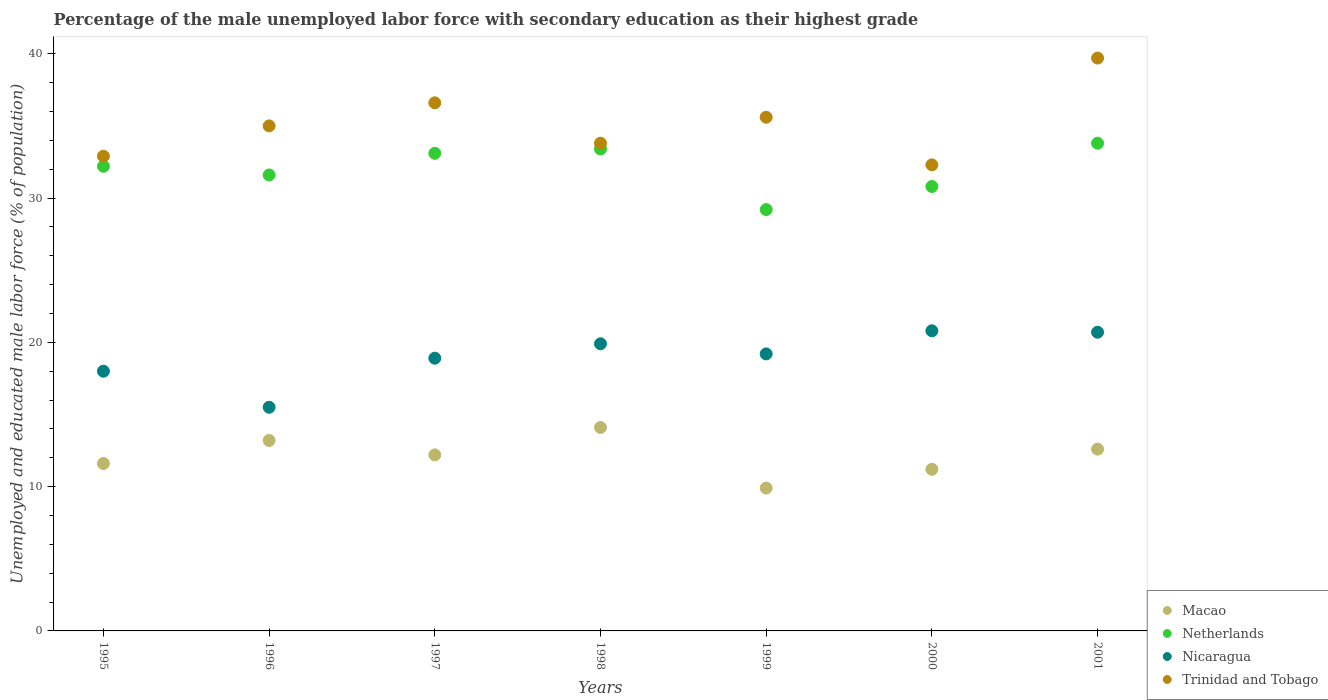How many different coloured dotlines are there?
Your answer should be very brief. 4. What is the percentage of the unemployed male labor force with secondary education in Netherlands in 2001?
Make the answer very short. 33.8. Across all years, what is the maximum percentage of the unemployed male labor force with secondary education in Trinidad and Tobago?
Make the answer very short. 39.7. Across all years, what is the minimum percentage of the unemployed male labor force with secondary education in Macao?
Keep it short and to the point. 9.9. What is the total percentage of the unemployed male labor force with secondary education in Macao in the graph?
Your answer should be compact. 84.8. What is the difference between the percentage of the unemployed male labor force with secondary education in Nicaragua in 1998 and that in 2001?
Give a very brief answer. -0.8. What is the difference between the percentage of the unemployed male labor force with secondary education in Macao in 1997 and the percentage of the unemployed male labor force with secondary education in Nicaragua in 1995?
Offer a terse response. -5.8. What is the average percentage of the unemployed male labor force with secondary education in Trinidad and Tobago per year?
Offer a terse response. 35.13. In the year 1997, what is the difference between the percentage of the unemployed male labor force with secondary education in Trinidad and Tobago and percentage of the unemployed male labor force with secondary education in Macao?
Offer a very short reply. 24.4. What is the ratio of the percentage of the unemployed male labor force with secondary education in Nicaragua in 1998 to that in 2000?
Keep it short and to the point. 0.96. Is the difference between the percentage of the unemployed male labor force with secondary education in Trinidad and Tobago in 1996 and 2000 greater than the difference between the percentage of the unemployed male labor force with secondary education in Macao in 1996 and 2000?
Keep it short and to the point. Yes. What is the difference between the highest and the second highest percentage of the unemployed male labor force with secondary education in Macao?
Offer a very short reply. 0.9. What is the difference between the highest and the lowest percentage of the unemployed male labor force with secondary education in Macao?
Offer a very short reply. 4.2. How many years are there in the graph?
Offer a very short reply. 7. Does the graph contain any zero values?
Offer a very short reply. No. Where does the legend appear in the graph?
Provide a short and direct response. Bottom right. What is the title of the graph?
Offer a very short reply. Percentage of the male unemployed labor force with secondary education as their highest grade. Does "Belarus" appear as one of the legend labels in the graph?
Ensure brevity in your answer.  No. What is the label or title of the Y-axis?
Keep it short and to the point. Unemployed and educated male labor force (% of population). What is the Unemployed and educated male labor force (% of population) in Macao in 1995?
Offer a terse response. 11.6. What is the Unemployed and educated male labor force (% of population) in Netherlands in 1995?
Ensure brevity in your answer.  32.2. What is the Unemployed and educated male labor force (% of population) in Nicaragua in 1995?
Make the answer very short. 18. What is the Unemployed and educated male labor force (% of population) of Trinidad and Tobago in 1995?
Your answer should be compact. 32.9. What is the Unemployed and educated male labor force (% of population) in Macao in 1996?
Make the answer very short. 13.2. What is the Unemployed and educated male labor force (% of population) in Netherlands in 1996?
Offer a terse response. 31.6. What is the Unemployed and educated male labor force (% of population) of Nicaragua in 1996?
Ensure brevity in your answer.  15.5. What is the Unemployed and educated male labor force (% of population) in Trinidad and Tobago in 1996?
Keep it short and to the point. 35. What is the Unemployed and educated male labor force (% of population) of Macao in 1997?
Keep it short and to the point. 12.2. What is the Unemployed and educated male labor force (% of population) of Netherlands in 1997?
Keep it short and to the point. 33.1. What is the Unemployed and educated male labor force (% of population) in Nicaragua in 1997?
Your response must be concise. 18.9. What is the Unemployed and educated male labor force (% of population) of Trinidad and Tobago in 1997?
Your response must be concise. 36.6. What is the Unemployed and educated male labor force (% of population) of Macao in 1998?
Ensure brevity in your answer.  14.1. What is the Unemployed and educated male labor force (% of population) of Netherlands in 1998?
Keep it short and to the point. 33.4. What is the Unemployed and educated male labor force (% of population) of Nicaragua in 1998?
Offer a very short reply. 19.9. What is the Unemployed and educated male labor force (% of population) of Trinidad and Tobago in 1998?
Ensure brevity in your answer.  33.8. What is the Unemployed and educated male labor force (% of population) in Macao in 1999?
Make the answer very short. 9.9. What is the Unemployed and educated male labor force (% of population) of Netherlands in 1999?
Your answer should be compact. 29.2. What is the Unemployed and educated male labor force (% of population) in Nicaragua in 1999?
Your response must be concise. 19.2. What is the Unemployed and educated male labor force (% of population) of Trinidad and Tobago in 1999?
Provide a short and direct response. 35.6. What is the Unemployed and educated male labor force (% of population) in Macao in 2000?
Your response must be concise. 11.2. What is the Unemployed and educated male labor force (% of population) in Netherlands in 2000?
Your answer should be compact. 30.8. What is the Unemployed and educated male labor force (% of population) in Nicaragua in 2000?
Provide a succinct answer. 20.8. What is the Unemployed and educated male labor force (% of population) in Trinidad and Tobago in 2000?
Make the answer very short. 32.3. What is the Unemployed and educated male labor force (% of population) in Macao in 2001?
Provide a succinct answer. 12.6. What is the Unemployed and educated male labor force (% of population) of Netherlands in 2001?
Give a very brief answer. 33.8. What is the Unemployed and educated male labor force (% of population) in Nicaragua in 2001?
Ensure brevity in your answer.  20.7. What is the Unemployed and educated male labor force (% of population) of Trinidad and Tobago in 2001?
Give a very brief answer. 39.7. Across all years, what is the maximum Unemployed and educated male labor force (% of population) of Macao?
Offer a very short reply. 14.1. Across all years, what is the maximum Unemployed and educated male labor force (% of population) of Netherlands?
Your answer should be very brief. 33.8. Across all years, what is the maximum Unemployed and educated male labor force (% of population) in Nicaragua?
Provide a short and direct response. 20.8. Across all years, what is the maximum Unemployed and educated male labor force (% of population) in Trinidad and Tobago?
Make the answer very short. 39.7. Across all years, what is the minimum Unemployed and educated male labor force (% of population) in Macao?
Your answer should be compact. 9.9. Across all years, what is the minimum Unemployed and educated male labor force (% of population) of Netherlands?
Offer a very short reply. 29.2. Across all years, what is the minimum Unemployed and educated male labor force (% of population) in Nicaragua?
Keep it short and to the point. 15.5. Across all years, what is the minimum Unemployed and educated male labor force (% of population) of Trinidad and Tobago?
Provide a short and direct response. 32.3. What is the total Unemployed and educated male labor force (% of population) of Macao in the graph?
Provide a succinct answer. 84.8. What is the total Unemployed and educated male labor force (% of population) of Netherlands in the graph?
Your answer should be very brief. 224.1. What is the total Unemployed and educated male labor force (% of population) of Nicaragua in the graph?
Your answer should be very brief. 133. What is the total Unemployed and educated male labor force (% of population) of Trinidad and Tobago in the graph?
Provide a short and direct response. 245.9. What is the difference between the Unemployed and educated male labor force (% of population) of Trinidad and Tobago in 1995 and that in 1996?
Offer a very short reply. -2.1. What is the difference between the Unemployed and educated male labor force (% of population) in Macao in 1995 and that in 1997?
Your answer should be compact. -0.6. What is the difference between the Unemployed and educated male labor force (% of population) in Netherlands in 1995 and that in 1998?
Ensure brevity in your answer.  -1.2. What is the difference between the Unemployed and educated male labor force (% of population) of Netherlands in 1995 and that in 1999?
Ensure brevity in your answer.  3. What is the difference between the Unemployed and educated male labor force (% of population) of Trinidad and Tobago in 1995 and that in 1999?
Keep it short and to the point. -2.7. What is the difference between the Unemployed and educated male labor force (% of population) of Netherlands in 1995 and that in 2000?
Provide a short and direct response. 1.4. What is the difference between the Unemployed and educated male labor force (% of population) in Nicaragua in 1995 and that in 2000?
Offer a terse response. -2.8. What is the difference between the Unemployed and educated male labor force (% of population) of Netherlands in 1995 and that in 2001?
Give a very brief answer. -1.6. What is the difference between the Unemployed and educated male labor force (% of population) of Nicaragua in 1995 and that in 2001?
Ensure brevity in your answer.  -2.7. What is the difference between the Unemployed and educated male labor force (% of population) of Trinidad and Tobago in 1995 and that in 2001?
Provide a short and direct response. -6.8. What is the difference between the Unemployed and educated male labor force (% of population) in Macao in 1996 and that in 1997?
Make the answer very short. 1. What is the difference between the Unemployed and educated male labor force (% of population) in Trinidad and Tobago in 1996 and that in 1997?
Give a very brief answer. -1.6. What is the difference between the Unemployed and educated male labor force (% of population) in Trinidad and Tobago in 1996 and that in 1998?
Ensure brevity in your answer.  1.2. What is the difference between the Unemployed and educated male labor force (% of population) in Macao in 1996 and that in 1999?
Provide a short and direct response. 3.3. What is the difference between the Unemployed and educated male labor force (% of population) of Netherlands in 1996 and that in 1999?
Provide a succinct answer. 2.4. What is the difference between the Unemployed and educated male labor force (% of population) of Nicaragua in 1996 and that in 1999?
Provide a succinct answer. -3.7. What is the difference between the Unemployed and educated male labor force (% of population) in Trinidad and Tobago in 1996 and that in 1999?
Offer a terse response. -0.6. What is the difference between the Unemployed and educated male labor force (% of population) of Macao in 1996 and that in 2000?
Your answer should be very brief. 2. What is the difference between the Unemployed and educated male labor force (% of population) of Nicaragua in 1996 and that in 2000?
Your response must be concise. -5.3. What is the difference between the Unemployed and educated male labor force (% of population) of Netherlands in 1996 and that in 2001?
Provide a short and direct response. -2.2. What is the difference between the Unemployed and educated male labor force (% of population) of Macao in 1997 and that in 1998?
Provide a short and direct response. -1.9. What is the difference between the Unemployed and educated male labor force (% of population) of Nicaragua in 1997 and that in 1998?
Provide a succinct answer. -1. What is the difference between the Unemployed and educated male labor force (% of population) in Macao in 1997 and that in 1999?
Keep it short and to the point. 2.3. What is the difference between the Unemployed and educated male labor force (% of population) in Netherlands in 1997 and that in 1999?
Your answer should be compact. 3.9. What is the difference between the Unemployed and educated male labor force (% of population) of Trinidad and Tobago in 1997 and that in 1999?
Provide a short and direct response. 1. What is the difference between the Unemployed and educated male labor force (% of population) of Macao in 1997 and that in 2000?
Your answer should be very brief. 1. What is the difference between the Unemployed and educated male labor force (% of population) of Netherlands in 1997 and that in 2000?
Provide a short and direct response. 2.3. What is the difference between the Unemployed and educated male labor force (% of population) of Trinidad and Tobago in 1997 and that in 2000?
Your answer should be very brief. 4.3. What is the difference between the Unemployed and educated male labor force (% of population) in Macao in 1997 and that in 2001?
Your answer should be very brief. -0.4. What is the difference between the Unemployed and educated male labor force (% of population) in Nicaragua in 1997 and that in 2001?
Provide a short and direct response. -1.8. What is the difference between the Unemployed and educated male labor force (% of population) in Macao in 1998 and that in 1999?
Ensure brevity in your answer.  4.2. What is the difference between the Unemployed and educated male labor force (% of population) in Nicaragua in 1998 and that in 1999?
Your answer should be very brief. 0.7. What is the difference between the Unemployed and educated male labor force (% of population) of Netherlands in 1998 and that in 2000?
Offer a terse response. 2.6. What is the difference between the Unemployed and educated male labor force (% of population) in Nicaragua in 1998 and that in 2000?
Your response must be concise. -0.9. What is the difference between the Unemployed and educated male labor force (% of population) in Trinidad and Tobago in 1998 and that in 2000?
Give a very brief answer. 1.5. What is the difference between the Unemployed and educated male labor force (% of population) of Nicaragua in 1998 and that in 2001?
Offer a terse response. -0.8. What is the difference between the Unemployed and educated male labor force (% of population) in Macao in 1999 and that in 2000?
Make the answer very short. -1.3. What is the difference between the Unemployed and educated male labor force (% of population) in Trinidad and Tobago in 1999 and that in 2001?
Your response must be concise. -4.1. What is the difference between the Unemployed and educated male labor force (% of population) of Netherlands in 2000 and that in 2001?
Provide a short and direct response. -3. What is the difference between the Unemployed and educated male labor force (% of population) of Nicaragua in 2000 and that in 2001?
Your response must be concise. 0.1. What is the difference between the Unemployed and educated male labor force (% of population) of Macao in 1995 and the Unemployed and educated male labor force (% of population) of Netherlands in 1996?
Provide a succinct answer. -20. What is the difference between the Unemployed and educated male labor force (% of population) of Macao in 1995 and the Unemployed and educated male labor force (% of population) of Trinidad and Tobago in 1996?
Make the answer very short. -23.4. What is the difference between the Unemployed and educated male labor force (% of population) in Netherlands in 1995 and the Unemployed and educated male labor force (% of population) in Nicaragua in 1996?
Keep it short and to the point. 16.7. What is the difference between the Unemployed and educated male labor force (% of population) in Netherlands in 1995 and the Unemployed and educated male labor force (% of population) in Trinidad and Tobago in 1996?
Give a very brief answer. -2.8. What is the difference between the Unemployed and educated male labor force (% of population) in Macao in 1995 and the Unemployed and educated male labor force (% of population) in Netherlands in 1997?
Your answer should be very brief. -21.5. What is the difference between the Unemployed and educated male labor force (% of population) in Macao in 1995 and the Unemployed and educated male labor force (% of population) in Nicaragua in 1997?
Make the answer very short. -7.3. What is the difference between the Unemployed and educated male labor force (% of population) in Nicaragua in 1995 and the Unemployed and educated male labor force (% of population) in Trinidad and Tobago in 1997?
Your response must be concise. -18.6. What is the difference between the Unemployed and educated male labor force (% of population) of Macao in 1995 and the Unemployed and educated male labor force (% of population) of Netherlands in 1998?
Keep it short and to the point. -21.8. What is the difference between the Unemployed and educated male labor force (% of population) of Macao in 1995 and the Unemployed and educated male labor force (% of population) of Trinidad and Tobago in 1998?
Provide a short and direct response. -22.2. What is the difference between the Unemployed and educated male labor force (% of population) in Nicaragua in 1995 and the Unemployed and educated male labor force (% of population) in Trinidad and Tobago in 1998?
Your answer should be very brief. -15.8. What is the difference between the Unemployed and educated male labor force (% of population) of Macao in 1995 and the Unemployed and educated male labor force (% of population) of Netherlands in 1999?
Your answer should be very brief. -17.6. What is the difference between the Unemployed and educated male labor force (% of population) of Netherlands in 1995 and the Unemployed and educated male labor force (% of population) of Nicaragua in 1999?
Give a very brief answer. 13. What is the difference between the Unemployed and educated male labor force (% of population) of Netherlands in 1995 and the Unemployed and educated male labor force (% of population) of Trinidad and Tobago in 1999?
Your answer should be very brief. -3.4. What is the difference between the Unemployed and educated male labor force (% of population) of Nicaragua in 1995 and the Unemployed and educated male labor force (% of population) of Trinidad and Tobago in 1999?
Offer a terse response. -17.6. What is the difference between the Unemployed and educated male labor force (% of population) of Macao in 1995 and the Unemployed and educated male labor force (% of population) of Netherlands in 2000?
Your response must be concise. -19.2. What is the difference between the Unemployed and educated male labor force (% of population) in Macao in 1995 and the Unemployed and educated male labor force (% of population) in Nicaragua in 2000?
Offer a terse response. -9.2. What is the difference between the Unemployed and educated male labor force (% of population) in Macao in 1995 and the Unemployed and educated male labor force (% of population) in Trinidad and Tobago in 2000?
Provide a short and direct response. -20.7. What is the difference between the Unemployed and educated male labor force (% of population) of Netherlands in 1995 and the Unemployed and educated male labor force (% of population) of Trinidad and Tobago in 2000?
Make the answer very short. -0.1. What is the difference between the Unemployed and educated male labor force (% of population) in Nicaragua in 1995 and the Unemployed and educated male labor force (% of population) in Trinidad and Tobago in 2000?
Give a very brief answer. -14.3. What is the difference between the Unemployed and educated male labor force (% of population) in Macao in 1995 and the Unemployed and educated male labor force (% of population) in Netherlands in 2001?
Make the answer very short. -22.2. What is the difference between the Unemployed and educated male labor force (% of population) in Macao in 1995 and the Unemployed and educated male labor force (% of population) in Nicaragua in 2001?
Provide a succinct answer. -9.1. What is the difference between the Unemployed and educated male labor force (% of population) of Macao in 1995 and the Unemployed and educated male labor force (% of population) of Trinidad and Tobago in 2001?
Your response must be concise. -28.1. What is the difference between the Unemployed and educated male labor force (% of population) in Netherlands in 1995 and the Unemployed and educated male labor force (% of population) in Nicaragua in 2001?
Your response must be concise. 11.5. What is the difference between the Unemployed and educated male labor force (% of population) in Nicaragua in 1995 and the Unemployed and educated male labor force (% of population) in Trinidad and Tobago in 2001?
Offer a very short reply. -21.7. What is the difference between the Unemployed and educated male labor force (% of population) in Macao in 1996 and the Unemployed and educated male labor force (% of population) in Netherlands in 1997?
Provide a short and direct response. -19.9. What is the difference between the Unemployed and educated male labor force (% of population) in Macao in 1996 and the Unemployed and educated male labor force (% of population) in Trinidad and Tobago in 1997?
Make the answer very short. -23.4. What is the difference between the Unemployed and educated male labor force (% of population) of Netherlands in 1996 and the Unemployed and educated male labor force (% of population) of Nicaragua in 1997?
Offer a very short reply. 12.7. What is the difference between the Unemployed and educated male labor force (% of population) of Netherlands in 1996 and the Unemployed and educated male labor force (% of population) of Trinidad and Tobago in 1997?
Give a very brief answer. -5. What is the difference between the Unemployed and educated male labor force (% of population) in Nicaragua in 1996 and the Unemployed and educated male labor force (% of population) in Trinidad and Tobago in 1997?
Provide a short and direct response. -21.1. What is the difference between the Unemployed and educated male labor force (% of population) of Macao in 1996 and the Unemployed and educated male labor force (% of population) of Netherlands in 1998?
Provide a short and direct response. -20.2. What is the difference between the Unemployed and educated male labor force (% of population) in Macao in 1996 and the Unemployed and educated male labor force (% of population) in Nicaragua in 1998?
Make the answer very short. -6.7. What is the difference between the Unemployed and educated male labor force (% of population) in Macao in 1996 and the Unemployed and educated male labor force (% of population) in Trinidad and Tobago in 1998?
Provide a short and direct response. -20.6. What is the difference between the Unemployed and educated male labor force (% of population) of Netherlands in 1996 and the Unemployed and educated male labor force (% of population) of Nicaragua in 1998?
Offer a very short reply. 11.7. What is the difference between the Unemployed and educated male labor force (% of population) of Netherlands in 1996 and the Unemployed and educated male labor force (% of population) of Trinidad and Tobago in 1998?
Ensure brevity in your answer.  -2.2. What is the difference between the Unemployed and educated male labor force (% of population) of Nicaragua in 1996 and the Unemployed and educated male labor force (% of population) of Trinidad and Tobago in 1998?
Provide a succinct answer. -18.3. What is the difference between the Unemployed and educated male labor force (% of population) in Macao in 1996 and the Unemployed and educated male labor force (% of population) in Netherlands in 1999?
Offer a terse response. -16. What is the difference between the Unemployed and educated male labor force (% of population) of Macao in 1996 and the Unemployed and educated male labor force (% of population) of Nicaragua in 1999?
Your answer should be very brief. -6. What is the difference between the Unemployed and educated male labor force (% of population) of Macao in 1996 and the Unemployed and educated male labor force (% of population) of Trinidad and Tobago in 1999?
Provide a succinct answer. -22.4. What is the difference between the Unemployed and educated male labor force (% of population) in Netherlands in 1996 and the Unemployed and educated male labor force (% of population) in Nicaragua in 1999?
Your response must be concise. 12.4. What is the difference between the Unemployed and educated male labor force (% of population) of Netherlands in 1996 and the Unemployed and educated male labor force (% of population) of Trinidad and Tobago in 1999?
Provide a succinct answer. -4. What is the difference between the Unemployed and educated male labor force (% of population) in Nicaragua in 1996 and the Unemployed and educated male labor force (% of population) in Trinidad and Tobago in 1999?
Your answer should be compact. -20.1. What is the difference between the Unemployed and educated male labor force (% of population) in Macao in 1996 and the Unemployed and educated male labor force (% of population) in Netherlands in 2000?
Provide a short and direct response. -17.6. What is the difference between the Unemployed and educated male labor force (% of population) of Macao in 1996 and the Unemployed and educated male labor force (% of population) of Nicaragua in 2000?
Make the answer very short. -7.6. What is the difference between the Unemployed and educated male labor force (% of population) of Macao in 1996 and the Unemployed and educated male labor force (% of population) of Trinidad and Tobago in 2000?
Provide a short and direct response. -19.1. What is the difference between the Unemployed and educated male labor force (% of population) in Netherlands in 1996 and the Unemployed and educated male labor force (% of population) in Nicaragua in 2000?
Make the answer very short. 10.8. What is the difference between the Unemployed and educated male labor force (% of population) in Nicaragua in 1996 and the Unemployed and educated male labor force (% of population) in Trinidad and Tobago in 2000?
Ensure brevity in your answer.  -16.8. What is the difference between the Unemployed and educated male labor force (% of population) in Macao in 1996 and the Unemployed and educated male labor force (% of population) in Netherlands in 2001?
Provide a succinct answer. -20.6. What is the difference between the Unemployed and educated male labor force (% of population) in Macao in 1996 and the Unemployed and educated male labor force (% of population) in Trinidad and Tobago in 2001?
Offer a very short reply. -26.5. What is the difference between the Unemployed and educated male labor force (% of population) of Netherlands in 1996 and the Unemployed and educated male labor force (% of population) of Nicaragua in 2001?
Give a very brief answer. 10.9. What is the difference between the Unemployed and educated male labor force (% of population) of Netherlands in 1996 and the Unemployed and educated male labor force (% of population) of Trinidad and Tobago in 2001?
Keep it short and to the point. -8.1. What is the difference between the Unemployed and educated male labor force (% of population) in Nicaragua in 1996 and the Unemployed and educated male labor force (% of population) in Trinidad and Tobago in 2001?
Provide a succinct answer. -24.2. What is the difference between the Unemployed and educated male labor force (% of population) of Macao in 1997 and the Unemployed and educated male labor force (% of population) of Netherlands in 1998?
Provide a succinct answer. -21.2. What is the difference between the Unemployed and educated male labor force (% of population) of Macao in 1997 and the Unemployed and educated male labor force (% of population) of Nicaragua in 1998?
Your answer should be compact. -7.7. What is the difference between the Unemployed and educated male labor force (% of population) of Macao in 1997 and the Unemployed and educated male labor force (% of population) of Trinidad and Tobago in 1998?
Your answer should be very brief. -21.6. What is the difference between the Unemployed and educated male labor force (% of population) in Netherlands in 1997 and the Unemployed and educated male labor force (% of population) in Nicaragua in 1998?
Offer a terse response. 13.2. What is the difference between the Unemployed and educated male labor force (% of population) in Nicaragua in 1997 and the Unemployed and educated male labor force (% of population) in Trinidad and Tobago in 1998?
Keep it short and to the point. -14.9. What is the difference between the Unemployed and educated male labor force (% of population) of Macao in 1997 and the Unemployed and educated male labor force (% of population) of Trinidad and Tobago in 1999?
Your answer should be compact. -23.4. What is the difference between the Unemployed and educated male labor force (% of population) of Netherlands in 1997 and the Unemployed and educated male labor force (% of population) of Nicaragua in 1999?
Offer a very short reply. 13.9. What is the difference between the Unemployed and educated male labor force (% of population) in Netherlands in 1997 and the Unemployed and educated male labor force (% of population) in Trinidad and Tobago in 1999?
Your answer should be very brief. -2.5. What is the difference between the Unemployed and educated male labor force (% of population) of Nicaragua in 1997 and the Unemployed and educated male labor force (% of population) of Trinidad and Tobago in 1999?
Make the answer very short. -16.7. What is the difference between the Unemployed and educated male labor force (% of population) of Macao in 1997 and the Unemployed and educated male labor force (% of population) of Netherlands in 2000?
Your answer should be very brief. -18.6. What is the difference between the Unemployed and educated male labor force (% of population) in Macao in 1997 and the Unemployed and educated male labor force (% of population) in Nicaragua in 2000?
Provide a succinct answer. -8.6. What is the difference between the Unemployed and educated male labor force (% of population) in Macao in 1997 and the Unemployed and educated male labor force (% of population) in Trinidad and Tobago in 2000?
Your answer should be compact. -20.1. What is the difference between the Unemployed and educated male labor force (% of population) of Netherlands in 1997 and the Unemployed and educated male labor force (% of population) of Trinidad and Tobago in 2000?
Your response must be concise. 0.8. What is the difference between the Unemployed and educated male labor force (% of population) of Nicaragua in 1997 and the Unemployed and educated male labor force (% of population) of Trinidad and Tobago in 2000?
Your response must be concise. -13.4. What is the difference between the Unemployed and educated male labor force (% of population) of Macao in 1997 and the Unemployed and educated male labor force (% of population) of Netherlands in 2001?
Ensure brevity in your answer.  -21.6. What is the difference between the Unemployed and educated male labor force (% of population) of Macao in 1997 and the Unemployed and educated male labor force (% of population) of Nicaragua in 2001?
Your response must be concise. -8.5. What is the difference between the Unemployed and educated male labor force (% of population) in Macao in 1997 and the Unemployed and educated male labor force (% of population) in Trinidad and Tobago in 2001?
Provide a succinct answer. -27.5. What is the difference between the Unemployed and educated male labor force (% of population) of Netherlands in 1997 and the Unemployed and educated male labor force (% of population) of Nicaragua in 2001?
Your answer should be compact. 12.4. What is the difference between the Unemployed and educated male labor force (% of population) in Netherlands in 1997 and the Unemployed and educated male labor force (% of population) in Trinidad and Tobago in 2001?
Your answer should be very brief. -6.6. What is the difference between the Unemployed and educated male labor force (% of population) of Nicaragua in 1997 and the Unemployed and educated male labor force (% of population) of Trinidad and Tobago in 2001?
Keep it short and to the point. -20.8. What is the difference between the Unemployed and educated male labor force (% of population) of Macao in 1998 and the Unemployed and educated male labor force (% of population) of Netherlands in 1999?
Your response must be concise. -15.1. What is the difference between the Unemployed and educated male labor force (% of population) of Macao in 1998 and the Unemployed and educated male labor force (% of population) of Nicaragua in 1999?
Keep it short and to the point. -5.1. What is the difference between the Unemployed and educated male labor force (% of population) in Macao in 1998 and the Unemployed and educated male labor force (% of population) in Trinidad and Tobago in 1999?
Give a very brief answer. -21.5. What is the difference between the Unemployed and educated male labor force (% of population) of Nicaragua in 1998 and the Unemployed and educated male labor force (% of population) of Trinidad and Tobago in 1999?
Provide a succinct answer. -15.7. What is the difference between the Unemployed and educated male labor force (% of population) in Macao in 1998 and the Unemployed and educated male labor force (% of population) in Netherlands in 2000?
Give a very brief answer. -16.7. What is the difference between the Unemployed and educated male labor force (% of population) of Macao in 1998 and the Unemployed and educated male labor force (% of population) of Nicaragua in 2000?
Your answer should be very brief. -6.7. What is the difference between the Unemployed and educated male labor force (% of population) of Macao in 1998 and the Unemployed and educated male labor force (% of population) of Trinidad and Tobago in 2000?
Offer a terse response. -18.2. What is the difference between the Unemployed and educated male labor force (% of population) of Netherlands in 1998 and the Unemployed and educated male labor force (% of population) of Nicaragua in 2000?
Provide a succinct answer. 12.6. What is the difference between the Unemployed and educated male labor force (% of population) in Nicaragua in 1998 and the Unemployed and educated male labor force (% of population) in Trinidad and Tobago in 2000?
Keep it short and to the point. -12.4. What is the difference between the Unemployed and educated male labor force (% of population) in Macao in 1998 and the Unemployed and educated male labor force (% of population) in Netherlands in 2001?
Your answer should be very brief. -19.7. What is the difference between the Unemployed and educated male labor force (% of population) in Macao in 1998 and the Unemployed and educated male labor force (% of population) in Trinidad and Tobago in 2001?
Ensure brevity in your answer.  -25.6. What is the difference between the Unemployed and educated male labor force (% of population) in Netherlands in 1998 and the Unemployed and educated male labor force (% of population) in Trinidad and Tobago in 2001?
Offer a very short reply. -6.3. What is the difference between the Unemployed and educated male labor force (% of population) in Nicaragua in 1998 and the Unemployed and educated male labor force (% of population) in Trinidad and Tobago in 2001?
Offer a very short reply. -19.8. What is the difference between the Unemployed and educated male labor force (% of population) in Macao in 1999 and the Unemployed and educated male labor force (% of population) in Netherlands in 2000?
Provide a succinct answer. -20.9. What is the difference between the Unemployed and educated male labor force (% of population) of Macao in 1999 and the Unemployed and educated male labor force (% of population) of Trinidad and Tobago in 2000?
Provide a short and direct response. -22.4. What is the difference between the Unemployed and educated male labor force (% of population) of Netherlands in 1999 and the Unemployed and educated male labor force (% of population) of Nicaragua in 2000?
Your answer should be compact. 8.4. What is the difference between the Unemployed and educated male labor force (% of population) in Netherlands in 1999 and the Unemployed and educated male labor force (% of population) in Trinidad and Tobago in 2000?
Offer a very short reply. -3.1. What is the difference between the Unemployed and educated male labor force (% of population) of Macao in 1999 and the Unemployed and educated male labor force (% of population) of Netherlands in 2001?
Provide a short and direct response. -23.9. What is the difference between the Unemployed and educated male labor force (% of population) in Macao in 1999 and the Unemployed and educated male labor force (% of population) in Trinidad and Tobago in 2001?
Your answer should be compact. -29.8. What is the difference between the Unemployed and educated male labor force (% of population) of Netherlands in 1999 and the Unemployed and educated male labor force (% of population) of Nicaragua in 2001?
Provide a short and direct response. 8.5. What is the difference between the Unemployed and educated male labor force (% of population) in Netherlands in 1999 and the Unemployed and educated male labor force (% of population) in Trinidad and Tobago in 2001?
Keep it short and to the point. -10.5. What is the difference between the Unemployed and educated male labor force (% of population) of Nicaragua in 1999 and the Unemployed and educated male labor force (% of population) of Trinidad and Tobago in 2001?
Offer a very short reply. -20.5. What is the difference between the Unemployed and educated male labor force (% of population) in Macao in 2000 and the Unemployed and educated male labor force (% of population) in Netherlands in 2001?
Give a very brief answer. -22.6. What is the difference between the Unemployed and educated male labor force (% of population) of Macao in 2000 and the Unemployed and educated male labor force (% of population) of Trinidad and Tobago in 2001?
Give a very brief answer. -28.5. What is the difference between the Unemployed and educated male labor force (% of population) of Netherlands in 2000 and the Unemployed and educated male labor force (% of population) of Nicaragua in 2001?
Offer a terse response. 10.1. What is the difference between the Unemployed and educated male labor force (% of population) of Nicaragua in 2000 and the Unemployed and educated male labor force (% of population) of Trinidad and Tobago in 2001?
Your answer should be compact. -18.9. What is the average Unemployed and educated male labor force (% of population) of Macao per year?
Offer a very short reply. 12.11. What is the average Unemployed and educated male labor force (% of population) in Netherlands per year?
Your answer should be compact. 32.01. What is the average Unemployed and educated male labor force (% of population) in Trinidad and Tobago per year?
Your response must be concise. 35.13. In the year 1995, what is the difference between the Unemployed and educated male labor force (% of population) of Macao and Unemployed and educated male labor force (% of population) of Netherlands?
Offer a very short reply. -20.6. In the year 1995, what is the difference between the Unemployed and educated male labor force (% of population) of Macao and Unemployed and educated male labor force (% of population) of Nicaragua?
Ensure brevity in your answer.  -6.4. In the year 1995, what is the difference between the Unemployed and educated male labor force (% of population) of Macao and Unemployed and educated male labor force (% of population) of Trinidad and Tobago?
Offer a terse response. -21.3. In the year 1995, what is the difference between the Unemployed and educated male labor force (% of population) in Netherlands and Unemployed and educated male labor force (% of population) in Nicaragua?
Ensure brevity in your answer.  14.2. In the year 1995, what is the difference between the Unemployed and educated male labor force (% of population) in Netherlands and Unemployed and educated male labor force (% of population) in Trinidad and Tobago?
Your answer should be compact. -0.7. In the year 1995, what is the difference between the Unemployed and educated male labor force (% of population) in Nicaragua and Unemployed and educated male labor force (% of population) in Trinidad and Tobago?
Your answer should be very brief. -14.9. In the year 1996, what is the difference between the Unemployed and educated male labor force (% of population) of Macao and Unemployed and educated male labor force (% of population) of Netherlands?
Make the answer very short. -18.4. In the year 1996, what is the difference between the Unemployed and educated male labor force (% of population) of Macao and Unemployed and educated male labor force (% of population) of Nicaragua?
Your answer should be compact. -2.3. In the year 1996, what is the difference between the Unemployed and educated male labor force (% of population) in Macao and Unemployed and educated male labor force (% of population) in Trinidad and Tobago?
Keep it short and to the point. -21.8. In the year 1996, what is the difference between the Unemployed and educated male labor force (% of population) of Netherlands and Unemployed and educated male labor force (% of population) of Trinidad and Tobago?
Your answer should be very brief. -3.4. In the year 1996, what is the difference between the Unemployed and educated male labor force (% of population) of Nicaragua and Unemployed and educated male labor force (% of population) of Trinidad and Tobago?
Give a very brief answer. -19.5. In the year 1997, what is the difference between the Unemployed and educated male labor force (% of population) in Macao and Unemployed and educated male labor force (% of population) in Netherlands?
Your response must be concise. -20.9. In the year 1997, what is the difference between the Unemployed and educated male labor force (% of population) of Macao and Unemployed and educated male labor force (% of population) of Nicaragua?
Offer a terse response. -6.7. In the year 1997, what is the difference between the Unemployed and educated male labor force (% of population) in Macao and Unemployed and educated male labor force (% of population) in Trinidad and Tobago?
Ensure brevity in your answer.  -24.4. In the year 1997, what is the difference between the Unemployed and educated male labor force (% of population) in Nicaragua and Unemployed and educated male labor force (% of population) in Trinidad and Tobago?
Your response must be concise. -17.7. In the year 1998, what is the difference between the Unemployed and educated male labor force (% of population) in Macao and Unemployed and educated male labor force (% of population) in Netherlands?
Your response must be concise. -19.3. In the year 1998, what is the difference between the Unemployed and educated male labor force (% of population) in Macao and Unemployed and educated male labor force (% of population) in Trinidad and Tobago?
Provide a short and direct response. -19.7. In the year 1998, what is the difference between the Unemployed and educated male labor force (% of population) in Netherlands and Unemployed and educated male labor force (% of population) in Trinidad and Tobago?
Your answer should be compact. -0.4. In the year 1998, what is the difference between the Unemployed and educated male labor force (% of population) of Nicaragua and Unemployed and educated male labor force (% of population) of Trinidad and Tobago?
Your answer should be very brief. -13.9. In the year 1999, what is the difference between the Unemployed and educated male labor force (% of population) of Macao and Unemployed and educated male labor force (% of population) of Netherlands?
Your answer should be compact. -19.3. In the year 1999, what is the difference between the Unemployed and educated male labor force (% of population) in Macao and Unemployed and educated male labor force (% of population) in Trinidad and Tobago?
Give a very brief answer. -25.7. In the year 1999, what is the difference between the Unemployed and educated male labor force (% of population) of Nicaragua and Unemployed and educated male labor force (% of population) of Trinidad and Tobago?
Your answer should be compact. -16.4. In the year 2000, what is the difference between the Unemployed and educated male labor force (% of population) in Macao and Unemployed and educated male labor force (% of population) in Netherlands?
Ensure brevity in your answer.  -19.6. In the year 2000, what is the difference between the Unemployed and educated male labor force (% of population) of Macao and Unemployed and educated male labor force (% of population) of Trinidad and Tobago?
Your response must be concise. -21.1. In the year 2000, what is the difference between the Unemployed and educated male labor force (% of population) in Netherlands and Unemployed and educated male labor force (% of population) in Trinidad and Tobago?
Provide a succinct answer. -1.5. In the year 2001, what is the difference between the Unemployed and educated male labor force (% of population) in Macao and Unemployed and educated male labor force (% of population) in Netherlands?
Your answer should be compact. -21.2. In the year 2001, what is the difference between the Unemployed and educated male labor force (% of population) in Macao and Unemployed and educated male labor force (% of population) in Trinidad and Tobago?
Your answer should be compact. -27.1. In the year 2001, what is the difference between the Unemployed and educated male labor force (% of population) of Netherlands and Unemployed and educated male labor force (% of population) of Nicaragua?
Offer a terse response. 13.1. In the year 2001, what is the difference between the Unemployed and educated male labor force (% of population) in Nicaragua and Unemployed and educated male labor force (% of population) in Trinidad and Tobago?
Your answer should be very brief. -19. What is the ratio of the Unemployed and educated male labor force (% of population) of Macao in 1995 to that in 1996?
Ensure brevity in your answer.  0.88. What is the ratio of the Unemployed and educated male labor force (% of population) of Nicaragua in 1995 to that in 1996?
Your answer should be very brief. 1.16. What is the ratio of the Unemployed and educated male labor force (% of population) of Macao in 1995 to that in 1997?
Ensure brevity in your answer.  0.95. What is the ratio of the Unemployed and educated male labor force (% of population) in Netherlands in 1995 to that in 1997?
Offer a terse response. 0.97. What is the ratio of the Unemployed and educated male labor force (% of population) of Trinidad and Tobago in 1995 to that in 1997?
Your answer should be very brief. 0.9. What is the ratio of the Unemployed and educated male labor force (% of population) in Macao in 1995 to that in 1998?
Ensure brevity in your answer.  0.82. What is the ratio of the Unemployed and educated male labor force (% of population) in Netherlands in 1995 to that in 1998?
Provide a succinct answer. 0.96. What is the ratio of the Unemployed and educated male labor force (% of population) in Nicaragua in 1995 to that in 1998?
Offer a terse response. 0.9. What is the ratio of the Unemployed and educated male labor force (% of population) in Trinidad and Tobago in 1995 to that in 1998?
Offer a terse response. 0.97. What is the ratio of the Unemployed and educated male labor force (% of population) of Macao in 1995 to that in 1999?
Make the answer very short. 1.17. What is the ratio of the Unemployed and educated male labor force (% of population) in Netherlands in 1995 to that in 1999?
Your response must be concise. 1.1. What is the ratio of the Unemployed and educated male labor force (% of population) in Nicaragua in 1995 to that in 1999?
Your answer should be very brief. 0.94. What is the ratio of the Unemployed and educated male labor force (% of population) of Trinidad and Tobago in 1995 to that in 1999?
Offer a terse response. 0.92. What is the ratio of the Unemployed and educated male labor force (% of population) in Macao in 1995 to that in 2000?
Keep it short and to the point. 1.04. What is the ratio of the Unemployed and educated male labor force (% of population) of Netherlands in 1995 to that in 2000?
Your answer should be very brief. 1.05. What is the ratio of the Unemployed and educated male labor force (% of population) of Nicaragua in 1995 to that in 2000?
Ensure brevity in your answer.  0.87. What is the ratio of the Unemployed and educated male labor force (% of population) of Trinidad and Tobago in 1995 to that in 2000?
Your answer should be very brief. 1.02. What is the ratio of the Unemployed and educated male labor force (% of population) of Macao in 1995 to that in 2001?
Your answer should be very brief. 0.92. What is the ratio of the Unemployed and educated male labor force (% of population) of Netherlands in 1995 to that in 2001?
Give a very brief answer. 0.95. What is the ratio of the Unemployed and educated male labor force (% of population) of Nicaragua in 1995 to that in 2001?
Make the answer very short. 0.87. What is the ratio of the Unemployed and educated male labor force (% of population) of Trinidad and Tobago in 1995 to that in 2001?
Provide a short and direct response. 0.83. What is the ratio of the Unemployed and educated male labor force (% of population) in Macao in 1996 to that in 1997?
Give a very brief answer. 1.08. What is the ratio of the Unemployed and educated male labor force (% of population) of Netherlands in 1996 to that in 1997?
Keep it short and to the point. 0.95. What is the ratio of the Unemployed and educated male labor force (% of population) of Nicaragua in 1996 to that in 1997?
Provide a succinct answer. 0.82. What is the ratio of the Unemployed and educated male labor force (% of population) in Trinidad and Tobago in 1996 to that in 1997?
Your answer should be compact. 0.96. What is the ratio of the Unemployed and educated male labor force (% of population) of Macao in 1996 to that in 1998?
Your answer should be compact. 0.94. What is the ratio of the Unemployed and educated male labor force (% of population) of Netherlands in 1996 to that in 1998?
Offer a very short reply. 0.95. What is the ratio of the Unemployed and educated male labor force (% of population) in Nicaragua in 1996 to that in 1998?
Your answer should be very brief. 0.78. What is the ratio of the Unemployed and educated male labor force (% of population) of Trinidad and Tobago in 1996 to that in 1998?
Provide a short and direct response. 1.04. What is the ratio of the Unemployed and educated male labor force (% of population) in Macao in 1996 to that in 1999?
Give a very brief answer. 1.33. What is the ratio of the Unemployed and educated male labor force (% of population) of Netherlands in 1996 to that in 1999?
Your answer should be very brief. 1.08. What is the ratio of the Unemployed and educated male labor force (% of population) of Nicaragua in 1996 to that in 1999?
Keep it short and to the point. 0.81. What is the ratio of the Unemployed and educated male labor force (% of population) in Trinidad and Tobago in 1996 to that in 1999?
Provide a short and direct response. 0.98. What is the ratio of the Unemployed and educated male labor force (% of population) of Macao in 1996 to that in 2000?
Provide a short and direct response. 1.18. What is the ratio of the Unemployed and educated male labor force (% of population) of Nicaragua in 1996 to that in 2000?
Give a very brief answer. 0.75. What is the ratio of the Unemployed and educated male labor force (% of population) in Trinidad and Tobago in 1996 to that in 2000?
Ensure brevity in your answer.  1.08. What is the ratio of the Unemployed and educated male labor force (% of population) of Macao in 1996 to that in 2001?
Your answer should be compact. 1.05. What is the ratio of the Unemployed and educated male labor force (% of population) of Netherlands in 1996 to that in 2001?
Give a very brief answer. 0.93. What is the ratio of the Unemployed and educated male labor force (% of population) in Nicaragua in 1996 to that in 2001?
Your answer should be compact. 0.75. What is the ratio of the Unemployed and educated male labor force (% of population) of Trinidad and Tobago in 1996 to that in 2001?
Provide a short and direct response. 0.88. What is the ratio of the Unemployed and educated male labor force (% of population) in Macao in 1997 to that in 1998?
Provide a succinct answer. 0.87. What is the ratio of the Unemployed and educated male labor force (% of population) of Netherlands in 1997 to that in 1998?
Ensure brevity in your answer.  0.99. What is the ratio of the Unemployed and educated male labor force (% of population) of Nicaragua in 1997 to that in 1998?
Offer a terse response. 0.95. What is the ratio of the Unemployed and educated male labor force (% of population) of Trinidad and Tobago in 1997 to that in 1998?
Provide a succinct answer. 1.08. What is the ratio of the Unemployed and educated male labor force (% of population) of Macao in 1997 to that in 1999?
Offer a very short reply. 1.23. What is the ratio of the Unemployed and educated male labor force (% of population) of Netherlands in 1997 to that in 1999?
Your answer should be very brief. 1.13. What is the ratio of the Unemployed and educated male labor force (% of population) of Nicaragua in 1997 to that in 1999?
Provide a succinct answer. 0.98. What is the ratio of the Unemployed and educated male labor force (% of population) of Trinidad and Tobago in 1997 to that in 1999?
Provide a short and direct response. 1.03. What is the ratio of the Unemployed and educated male labor force (% of population) of Macao in 1997 to that in 2000?
Your answer should be very brief. 1.09. What is the ratio of the Unemployed and educated male labor force (% of population) in Netherlands in 1997 to that in 2000?
Offer a terse response. 1.07. What is the ratio of the Unemployed and educated male labor force (% of population) in Nicaragua in 1997 to that in 2000?
Give a very brief answer. 0.91. What is the ratio of the Unemployed and educated male labor force (% of population) in Trinidad and Tobago in 1997 to that in 2000?
Make the answer very short. 1.13. What is the ratio of the Unemployed and educated male labor force (% of population) in Macao in 1997 to that in 2001?
Offer a very short reply. 0.97. What is the ratio of the Unemployed and educated male labor force (% of population) in Netherlands in 1997 to that in 2001?
Ensure brevity in your answer.  0.98. What is the ratio of the Unemployed and educated male labor force (% of population) of Nicaragua in 1997 to that in 2001?
Provide a succinct answer. 0.91. What is the ratio of the Unemployed and educated male labor force (% of population) of Trinidad and Tobago in 1997 to that in 2001?
Give a very brief answer. 0.92. What is the ratio of the Unemployed and educated male labor force (% of population) of Macao in 1998 to that in 1999?
Your answer should be very brief. 1.42. What is the ratio of the Unemployed and educated male labor force (% of population) of Netherlands in 1998 to that in 1999?
Provide a short and direct response. 1.14. What is the ratio of the Unemployed and educated male labor force (% of population) in Nicaragua in 1998 to that in 1999?
Offer a very short reply. 1.04. What is the ratio of the Unemployed and educated male labor force (% of population) of Trinidad and Tobago in 1998 to that in 1999?
Your response must be concise. 0.95. What is the ratio of the Unemployed and educated male labor force (% of population) of Macao in 1998 to that in 2000?
Your answer should be compact. 1.26. What is the ratio of the Unemployed and educated male labor force (% of population) in Netherlands in 1998 to that in 2000?
Give a very brief answer. 1.08. What is the ratio of the Unemployed and educated male labor force (% of population) of Nicaragua in 1998 to that in 2000?
Your answer should be compact. 0.96. What is the ratio of the Unemployed and educated male labor force (% of population) in Trinidad and Tobago in 1998 to that in 2000?
Provide a succinct answer. 1.05. What is the ratio of the Unemployed and educated male labor force (% of population) in Macao in 1998 to that in 2001?
Keep it short and to the point. 1.12. What is the ratio of the Unemployed and educated male labor force (% of population) of Netherlands in 1998 to that in 2001?
Your answer should be compact. 0.99. What is the ratio of the Unemployed and educated male labor force (% of population) of Nicaragua in 1998 to that in 2001?
Keep it short and to the point. 0.96. What is the ratio of the Unemployed and educated male labor force (% of population) of Trinidad and Tobago in 1998 to that in 2001?
Your answer should be compact. 0.85. What is the ratio of the Unemployed and educated male labor force (% of population) of Macao in 1999 to that in 2000?
Give a very brief answer. 0.88. What is the ratio of the Unemployed and educated male labor force (% of population) of Netherlands in 1999 to that in 2000?
Make the answer very short. 0.95. What is the ratio of the Unemployed and educated male labor force (% of population) in Nicaragua in 1999 to that in 2000?
Provide a short and direct response. 0.92. What is the ratio of the Unemployed and educated male labor force (% of population) of Trinidad and Tobago in 1999 to that in 2000?
Provide a succinct answer. 1.1. What is the ratio of the Unemployed and educated male labor force (% of population) in Macao in 1999 to that in 2001?
Your answer should be compact. 0.79. What is the ratio of the Unemployed and educated male labor force (% of population) in Netherlands in 1999 to that in 2001?
Provide a short and direct response. 0.86. What is the ratio of the Unemployed and educated male labor force (% of population) in Nicaragua in 1999 to that in 2001?
Give a very brief answer. 0.93. What is the ratio of the Unemployed and educated male labor force (% of population) in Trinidad and Tobago in 1999 to that in 2001?
Offer a very short reply. 0.9. What is the ratio of the Unemployed and educated male labor force (% of population) in Netherlands in 2000 to that in 2001?
Your response must be concise. 0.91. What is the ratio of the Unemployed and educated male labor force (% of population) of Trinidad and Tobago in 2000 to that in 2001?
Provide a succinct answer. 0.81. What is the difference between the highest and the second highest Unemployed and educated male labor force (% of population) of Netherlands?
Your answer should be very brief. 0.4. What is the difference between the highest and the lowest Unemployed and educated male labor force (% of population) in Netherlands?
Provide a short and direct response. 4.6. What is the difference between the highest and the lowest Unemployed and educated male labor force (% of population) in Nicaragua?
Provide a short and direct response. 5.3. What is the difference between the highest and the lowest Unemployed and educated male labor force (% of population) in Trinidad and Tobago?
Offer a very short reply. 7.4. 